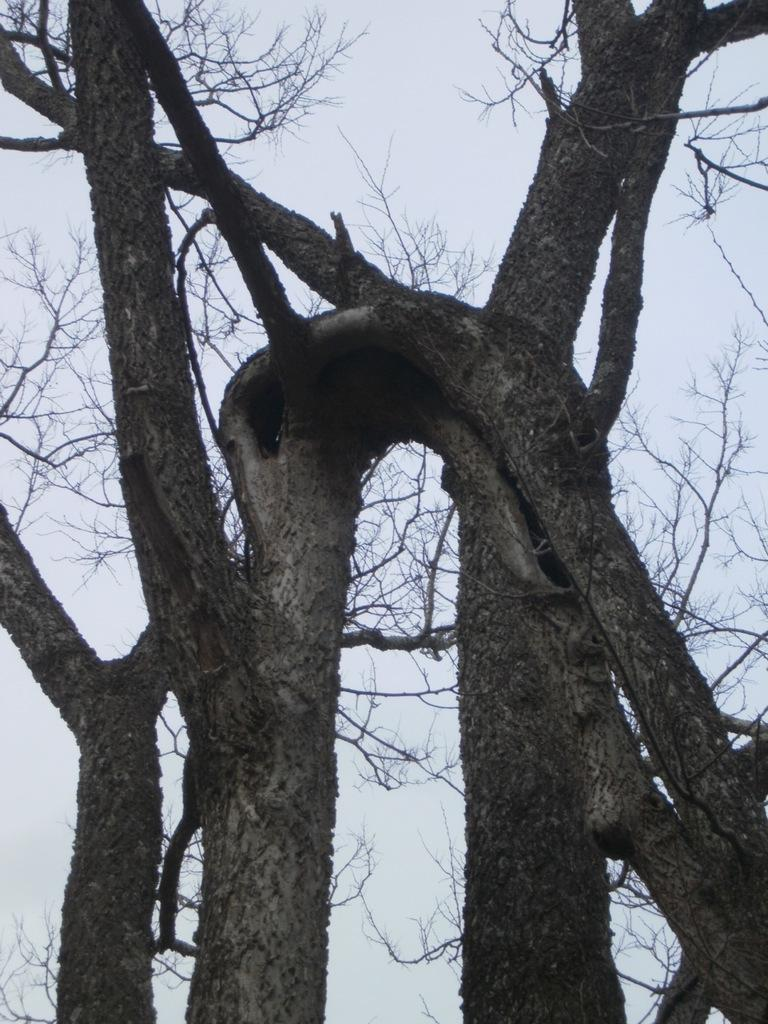Where was the image taken? The image was taken outdoors. What can be seen at the top of the image? The sky is visible at the top of the image. What type of vegetation is present in the image? There are trees in the middle of the image. What type of crack is visible in the image? There is no crack present in the image. What emotion is being expressed by the trees in the image? Trees do not express emotions, so this question cannot be answered. 